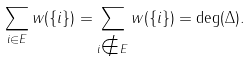<formula> <loc_0><loc_0><loc_500><loc_500>\sum _ { i \in E } w ( \{ i \} ) = \sum _ { i \notin E } w ( \{ i \} ) = \deg ( \Delta ) .</formula> 